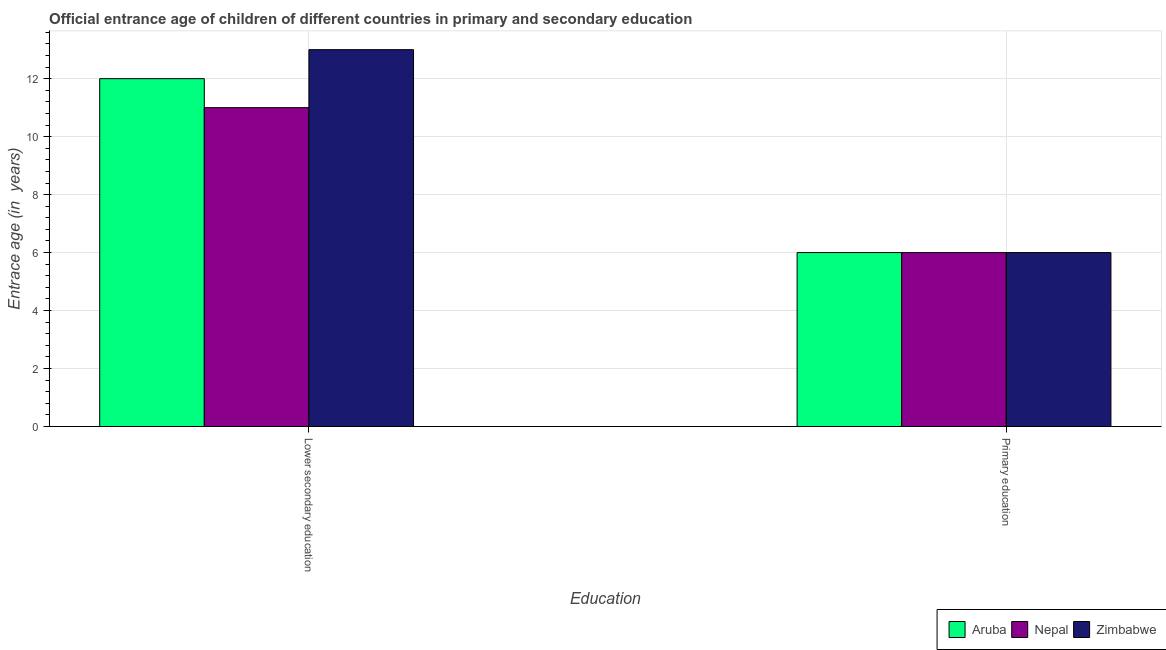How many different coloured bars are there?
Make the answer very short. 3. Are the number of bars on each tick of the X-axis equal?
Your answer should be compact. Yes. How many bars are there on the 1st tick from the left?
Make the answer very short. 3. How many bars are there on the 1st tick from the right?
Ensure brevity in your answer.  3. What is the label of the 1st group of bars from the left?
Give a very brief answer. Lower secondary education. What is the entrance age of chiildren in primary education in Zimbabwe?
Keep it short and to the point. 6. Across all countries, what is the maximum entrance age of chiildren in primary education?
Your response must be concise. 6. Across all countries, what is the minimum entrance age of chiildren in primary education?
Make the answer very short. 6. In which country was the entrance age of chiildren in primary education maximum?
Offer a terse response. Aruba. In which country was the entrance age of chiildren in primary education minimum?
Provide a succinct answer. Aruba. What is the total entrance age of chiildren in primary education in the graph?
Keep it short and to the point. 18. What is the difference between the entrance age of children in lower secondary education in Nepal and that in Aruba?
Keep it short and to the point. -1. What is the difference between the entrance age of children in lower secondary education in Zimbabwe and the entrance age of chiildren in primary education in Aruba?
Your answer should be compact. 7. What is the average entrance age of children in lower secondary education per country?
Provide a succinct answer. 12. What is the difference between the entrance age of children in lower secondary education and entrance age of chiildren in primary education in Aruba?
Keep it short and to the point. 6. In how many countries, is the entrance age of chiildren in primary education greater than 3.2 years?
Your response must be concise. 3. What is the ratio of the entrance age of children in lower secondary education in Aruba to that in Nepal?
Provide a succinct answer. 1.09. Is the entrance age of chiildren in primary education in Zimbabwe less than that in Nepal?
Give a very brief answer. No. In how many countries, is the entrance age of chiildren in primary education greater than the average entrance age of chiildren in primary education taken over all countries?
Provide a short and direct response. 0. What does the 2nd bar from the left in Lower secondary education represents?
Offer a terse response. Nepal. What does the 2nd bar from the right in Lower secondary education represents?
Give a very brief answer. Nepal. Are all the bars in the graph horizontal?
Ensure brevity in your answer.  No. What is the difference between two consecutive major ticks on the Y-axis?
Keep it short and to the point. 2. Are the values on the major ticks of Y-axis written in scientific E-notation?
Keep it short and to the point. No. Does the graph contain grids?
Offer a very short reply. Yes. Where does the legend appear in the graph?
Keep it short and to the point. Bottom right. How many legend labels are there?
Offer a very short reply. 3. What is the title of the graph?
Make the answer very short. Official entrance age of children of different countries in primary and secondary education. Does "Argentina" appear as one of the legend labels in the graph?
Make the answer very short. No. What is the label or title of the X-axis?
Offer a terse response. Education. What is the label or title of the Y-axis?
Give a very brief answer. Entrace age (in  years). What is the Entrace age (in  years) of Aruba in Lower secondary education?
Your response must be concise. 12. What is the Entrace age (in  years) of Zimbabwe in Lower secondary education?
Give a very brief answer. 13. What is the Entrace age (in  years) in Aruba in Primary education?
Give a very brief answer. 6. What is the Entrace age (in  years) in Nepal in Primary education?
Provide a short and direct response. 6. What is the Entrace age (in  years) in Zimbabwe in Primary education?
Provide a short and direct response. 6. Across all Education, what is the maximum Entrace age (in  years) of Zimbabwe?
Offer a terse response. 13. What is the total Entrace age (in  years) of Aruba in the graph?
Your response must be concise. 18. What is the total Entrace age (in  years) of Nepal in the graph?
Offer a very short reply. 17. What is the total Entrace age (in  years) of Zimbabwe in the graph?
Keep it short and to the point. 19. What is the difference between the Entrace age (in  years) in Aruba in Lower secondary education and that in Primary education?
Offer a terse response. 6. What is the difference between the Entrace age (in  years) in Zimbabwe in Lower secondary education and that in Primary education?
Your answer should be compact. 7. What is the difference between the Entrace age (in  years) of Aruba in Lower secondary education and the Entrace age (in  years) of Nepal in Primary education?
Provide a short and direct response. 6. What is the difference between the Entrace age (in  years) in Aruba in Lower secondary education and the Entrace age (in  years) in Zimbabwe in Primary education?
Offer a very short reply. 6. What is the difference between the Entrace age (in  years) in Nepal in Lower secondary education and the Entrace age (in  years) in Zimbabwe in Primary education?
Provide a succinct answer. 5. What is the average Entrace age (in  years) in Zimbabwe per Education?
Keep it short and to the point. 9.5. What is the difference between the Entrace age (in  years) in Aruba and Entrace age (in  years) in Nepal in Lower secondary education?
Provide a succinct answer. 1. What is the difference between the Entrace age (in  years) in Aruba and Entrace age (in  years) in Zimbabwe in Lower secondary education?
Your answer should be compact. -1. What is the difference between the Entrace age (in  years) in Nepal and Entrace age (in  years) in Zimbabwe in Lower secondary education?
Offer a very short reply. -2. What is the difference between the Entrace age (in  years) in Aruba and Entrace age (in  years) in Nepal in Primary education?
Ensure brevity in your answer.  0. What is the difference between the Entrace age (in  years) in Nepal and Entrace age (in  years) in Zimbabwe in Primary education?
Offer a terse response. 0. What is the ratio of the Entrace age (in  years) of Nepal in Lower secondary education to that in Primary education?
Make the answer very short. 1.83. What is the ratio of the Entrace age (in  years) of Zimbabwe in Lower secondary education to that in Primary education?
Provide a succinct answer. 2.17. What is the difference between the highest and the second highest Entrace age (in  years) in Nepal?
Provide a short and direct response. 5. What is the difference between the highest and the lowest Entrace age (in  years) in Nepal?
Make the answer very short. 5. What is the difference between the highest and the lowest Entrace age (in  years) in Zimbabwe?
Offer a terse response. 7. 